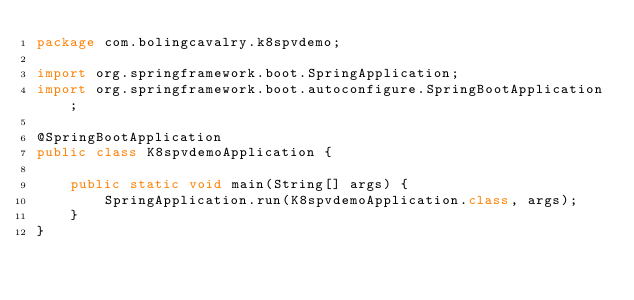Convert code to text. <code><loc_0><loc_0><loc_500><loc_500><_Java_>package com.bolingcavalry.k8spvdemo;

import org.springframework.boot.SpringApplication;
import org.springframework.boot.autoconfigure.SpringBootApplication;

@SpringBootApplication
public class K8spvdemoApplication {

	public static void main(String[] args) {
		SpringApplication.run(K8spvdemoApplication.class, args);
	}
}
</code> 